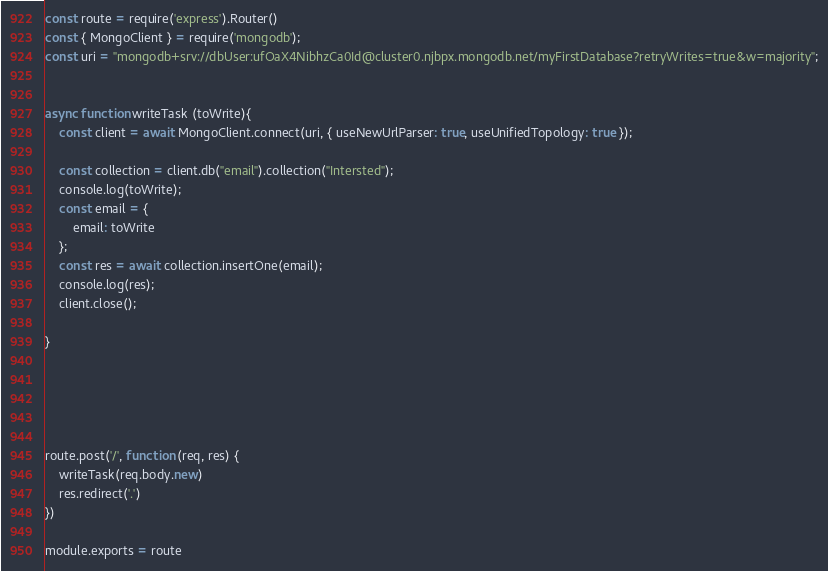<code> <loc_0><loc_0><loc_500><loc_500><_JavaScript_>const route = require('express').Router()
const { MongoClient } = require('mongodb');
const uri = "mongodb+srv://dbUser:ufOaX4NibhzCa0Id@cluster0.njbpx.mongodb.net/myFirstDatabase?retryWrites=true&w=majority";


async function writeTask (toWrite){
    const client = await MongoClient.connect(uri, { useNewUrlParser: true, useUnifiedTopology: true });
    
    const collection = client.db("email").collection("Intersted");
    console.log(toWrite);
    const email = {
        email: toWrite
    };
    const res = await collection.insertOne(email);
    console.log(res);
    client.close();
  
}





route.post('/', function (req, res) {
    writeTask(req.body.new)
    res.redirect('.')
})

module.exports = route</code> 